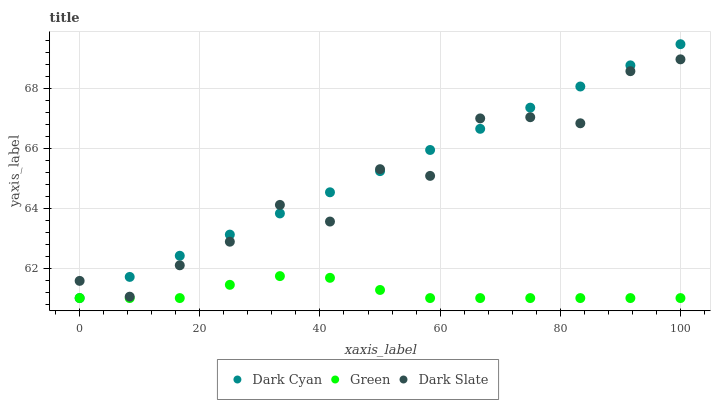Does Green have the minimum area under the curve?
Answer yes or no. Yes. Does Dark Cyan have the maximum area under the curve?
Answer yes or no. Yes. Does Dark Slate have the minimum area under the curve?
Answer yes or no. No. Does Dark Slate have the maximum area under the curve?
Answer yes or no. No. Is Dark Cyan the smoothest?
Answer yes or no. Yes. Is Dark Slate the roughest?
Answer yes or no. Yes. Is Green the smoothest?
Answer yes or no. No. Is Green the roughest?
Answer yes or no. No. Does Dark Cyan have the lowest value?
Answer yes or no. Yes. Does Dark Slate have the lowest value?
Answer yes or no. No. Does Dark Cyan have the highest value?
Answer yes or no. Yes. Does Dark Slate have the highest value?
Answer yes or no. No. Is Green less than Dark Slate?
Answer yes or no. Yes. Is Dark Slate greater than Green?
Answer yes or no. Yes. Does Dark Cyan intersect Dark Slate?
Answer yes or no. Yes. Is Dark Cyan less than Dark Slate?
Answer yes or no. No. Is Dark Cyan greater than Dark Slate?
Answer yes or no. No. Does Green intersect Dark Slate?
Answer yes or no. No. 